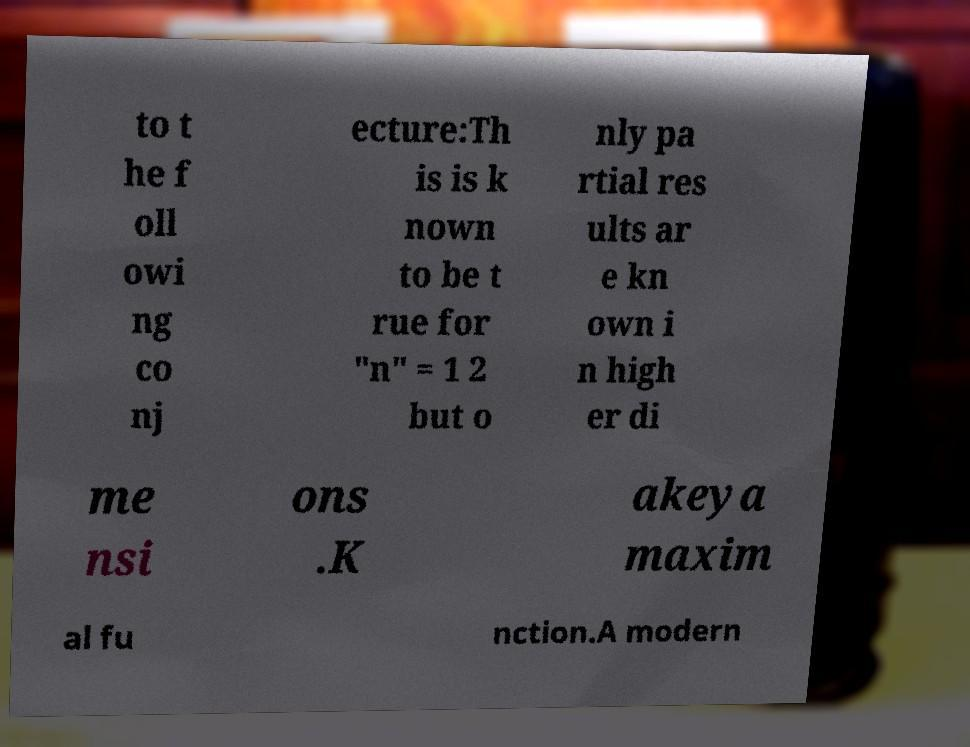Please identify and transcribe the text found in this image. to t he f oll owi ng co nj ecture:Th is is k nown to be t rue for "n" = 1 2 but o nly pa rtial res ults ar e kn own i n high er di me nsi ons .K akeya maxim al fu nction.A modern 